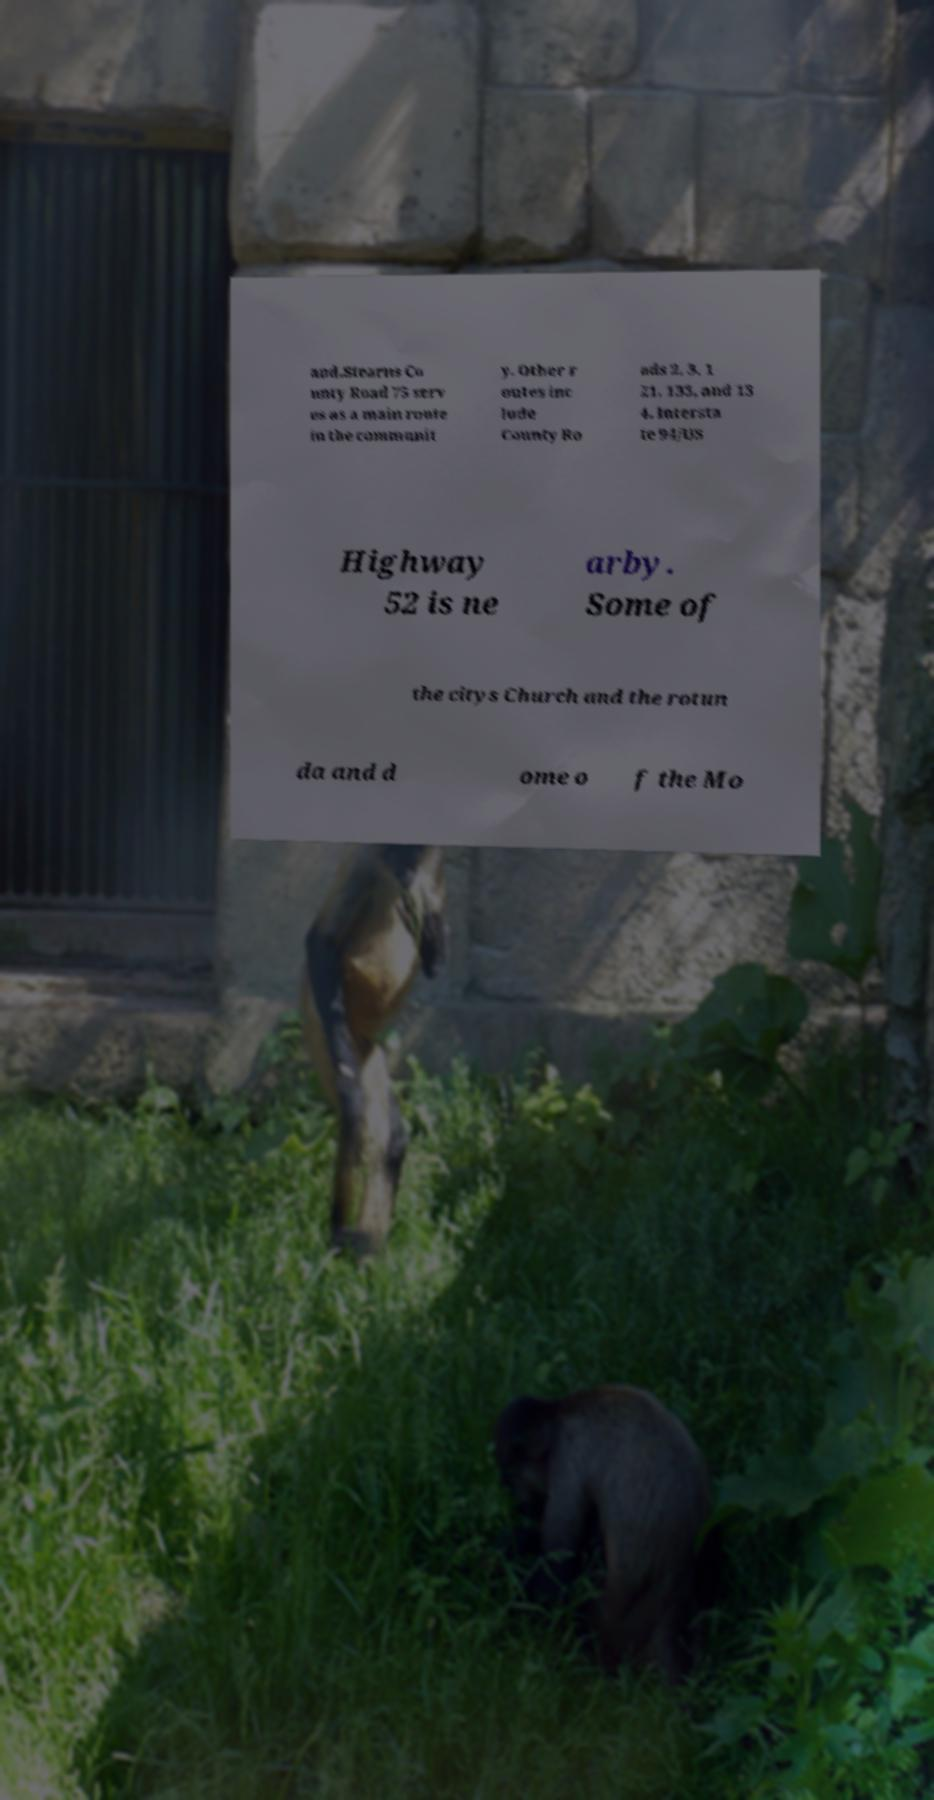What messages or text are displayed in this image? I need them in a readable, typed format. and.Stearns Co unty Road 75 serv es as a main route in the communit y. Other r outes inc lude County Ro ads 2, 3, 1 21, 133, and 13 4. Intersta te 94/US Highway 52 is ne arby. Some of the citys Church and the rotun da and d ome o f the Mo 